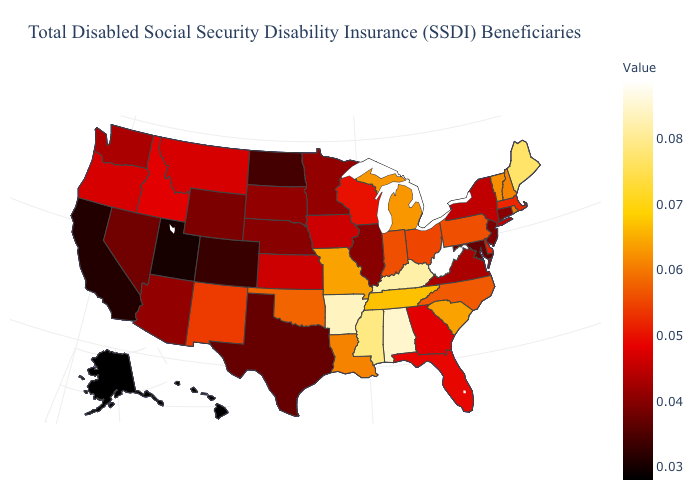Does Utah have the lowest value in the West?
Answer briefly. No. Among the states that border Maryland , which have the lowest value?
Write a very short answer. Virginia. Which states have the lowest value in the MidWest?
Give a very brief answer. North Dakota. Does Alaska have the lowest value in the USA?
Short answer required. Yes. Does Connecticut have the highest value in the USA?
Write a very short answer. No. Which states have the lowest value in the West?
Be succinct. Alaska, Hawaii. 